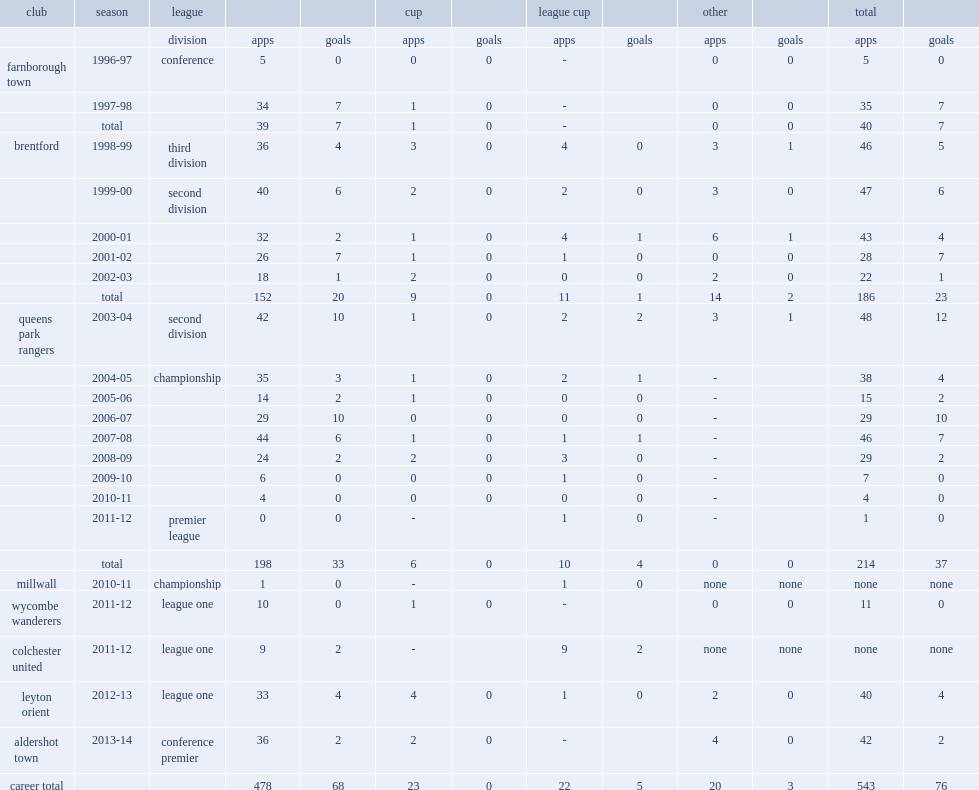Which league did martin rowlands appear for aldershot town in 2013-14 season? Conference premier. Could you parse the entire table? {'header': ['club', 'season', 'league', '', '', 'cup', '', 'league cup', '', 'other', '', 'total', ''], 'rows': [['', '', 'division', 'apps', 'goals', 'apps', 'goals', 'apps', 'goals', 'apps', 'goals', 'apps', 'goals'], ['farnborough town', '1996-97', 'conference', '5', '0', '0', '0', '-', '', '0', '0', '5', '0'], ['', '1997-98', '', '34', '7', '1', '0', '-', '', '0', '0', '35', '7'], ['', 'total', '', '39', '7', '1', '0', '-', '', '0', '0', '40', '7'], ['brentford', '1998-99', 'third division', '36', '4', '3', '0', '4', '0', '3', '1', '46', '5'], ['', '1999-00', 'second division', '40', '6', '2', '0', '2', '0', '3', '0', '47', '6'], ['', '2000-01', '', '32', '2', '1', '0', '4', '1', '6', '1', '43', '4'], ['', '2001-02', '', '26', '7', '1', '0', '1', '0', '0', '0', '28', '7'], ['', '2002-03', '', '18', '1', '2', '0', '0', '0', '2', '0', '22', '1'], ['', 'total', '', '152', '20', '9', '0', '11', '1', '14', '2', '186', '23'], ['queens park rangers', '2003-04', 'second division', '42', '10', '1', '0', '2', '2', '3', '1', '48', '12'], ['', '2004-05', 'championship', '35', '3', '1', '0', '2', '1', '-', '', '38', '4'], ['', '2005-06', '', '14', '2', '1', '0', '0', '0', '-', '', '15', '2'], ['', '2006-07', '', '29', '10', '0', '0', '0', '0', '-', '', '29', '10'], ['', '2007-08', '', '44', '6', '1', '0', '1', '1', '-', '', '46', '7'], ['', '2008-09', '', '24', '2', '2', '0', '3', '0', '-', '', '29', '2'], ['', '2009-10', '', '6', '0', '0', '0', '1', '0', '-', '', '7', '0'], ['', '2010-11', '', '4', '0', '0', '0', '0', '0', '-', '', '4', '0'], ['', '2011-12', 'premier league', '0', '0', '-', '', '1', '0', '-', '', '1', '0'], ['', 'total', '', '198', '33', '6', '0', '10', '4', '0', '0', '214', '37'], ['millwall', '2010-11', 'championship', '1', '0', '-', '', '1', '0', 'none', 'none', 'none', 'none'], ['wycombe wanderers', '2011-12', 'league one', '10', '0', '1', '0', '-', '', '0', '0', '11', '0'], ['colchester united', '2011-12', 'league one', '9', '2', '-', '', '9', '2', 'none', 'none', 'none', 'none'], ['leyton orient', '2012-13', 'league one', '33', '4', '4', '0', '1', '0', '2', '0', '40', '4'], ['aldershot town', '2013-14', 'conference premier', '36', '2', '2', '0', '-', '', '4', '0', '42', '2'], ['career total', '', '', '478', '68', '23', '0', '22', '5', '20', '3', '543', '76']]} Would you be able to parse every entry in this table? {'header': ['club', 'season', 'league', '', '', 'cup', '', 'league cup', '', 'other', '', 'total', ''], 'rows': [['', '', 'division', 'apps', 'goals', 'apps', 'goals', 'apps', 'goals', 'apps', 'goals', 'apps', 'goals'], ['farnborough town', '1996-97', 'conference', '5', '0', '0', '0', '-', '', '0', '0', '5', '0'], ['', '1997-98', '', '34', '7', '1', '0', '-', '', '0', '0', '35', '7'], ['', 'total', '', '39', '7', '1', '0', '-', '', '0', '0', '40', '7'], ['brentford', '1998-99', 'third division', '36', '4', '3', '0', '4', '0', '3', '1', '46', '5'], ['', '1999-00', 'second division', '40', '6', '2', '0', '2', '0', '3', '0', '47', '6'], ['', '2000-01', '', '32', '2', '1', '0', '4', '1', '6', '1', '43', '4'], ['', '2001-02', '', '26', '7', '1', '0', '1', '0', '0', '0', '28', '7'], ['', '2002-03', '', '18', '1', '2', '0', '0', '0', '2', '0', '22', '1'], ['', 'total', '', '152', '20', '9', '0', '11', '1', '14', '2', '186', '23'], ['queens park rangers', '2003-04', 'second division', '42', '10', '1', '0', '2', '2', '3', '1', '48', '12'], ['', '2004-05', 'championship', '35', '3', '1', '0', '2', '1', '-', '', '38', '4'], ['', '2005-06', '', '14', '2', '1', '0', '0', '0', '-', '', '15', '2'], ['', '2006-07', '', '29', '10', '0', '0', '0', '0', '-', '', '29', '10'], ['', '2007-08', '', '44', '6', '1', '0', '1', '1', '-', '', '46', '7'], ['', '2008-09', '', '24', '2', '2', '0', '3', '0', '-', '', '29', '2'], ['', '2009-10', '', '6', '0', '0', '0', '1', '0', '-', '', '7', '0'], ['', '2010-11', '', '4', '0', '0', '0', '0', '0', '-', '', '4', '0'], ['', '2011-12', 'premier league', '0', '0', '-', '', '1', '0', '-', '', '1', '0'], ['', 'total', '', '198', '33', '6', '0', '10', '4', '0', '0', '214', '37'], ['millwall', '2010-11', 'championship', '1', '0', '-', '', '1', '0', 'none', 'none', 'none', 'none'], ['wycombe wanderers', '2011-12', 'league one', '10', '0', '1', '0', '-', '', '0', '0', '11', '0'], ['colchester united', '2011-12', 'league one', '9', '2', '-', '', '9', '2', 'none', 'none', 'none', 'none'], ['leyton orient', '2012-13', 'league one', '33', '4', '4', '0', '1', '0', '2', '0', '40', '4'], ['aldershot town', '2013-14', 'conference premier', '36', '2', '2', '0', '-', '', '4', '0', '42', '2'], ['career total', '', '', '478', '68', '23', '0', '22', '5', '20', '3', '543', '76']]} From 1998- 2003, how many appearances did martin rowlands score with brentford? 186.0. From 1998- 2003, how many goals did martin rowlands score with brentford? 23.0. 